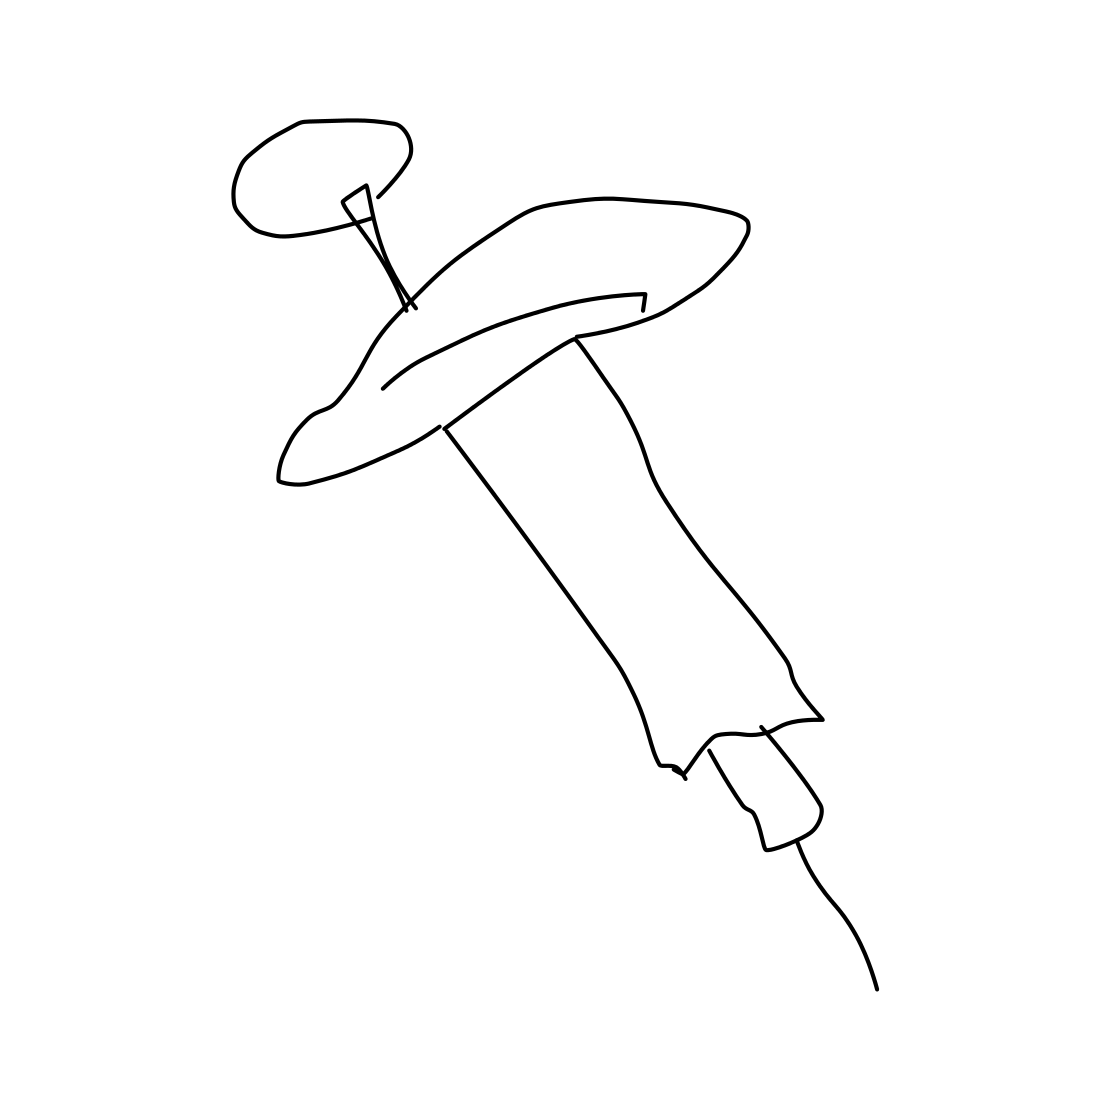In the scene, is a syringe in it? Yes 